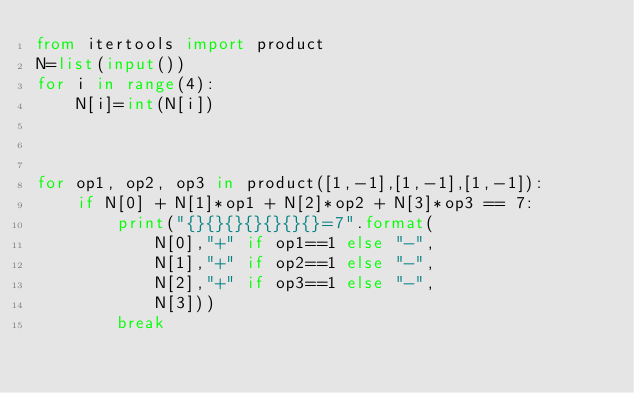Convert code to text. <code><loc_0><loc_0><loc_500><loc_500><_Python_>from itertools import product
N=list(input())
for i in range(4):
    N[i]=int(N[i])



for op1, op2, op3 in product([1,-1],[1,-1],[1,-1]):
    if N[0] + N[1]*op1 + N[2]*op2 + N[3]*op3 == 7:
        print("{}{}{}{}{}{}{}=7".format(
            N[0],"+" if op1==1 else "-",
            N[1],"+" if op2==1 else "-",
            N[2],"+" if op3==1 else "-",
            N[3]))
        break

</code> 